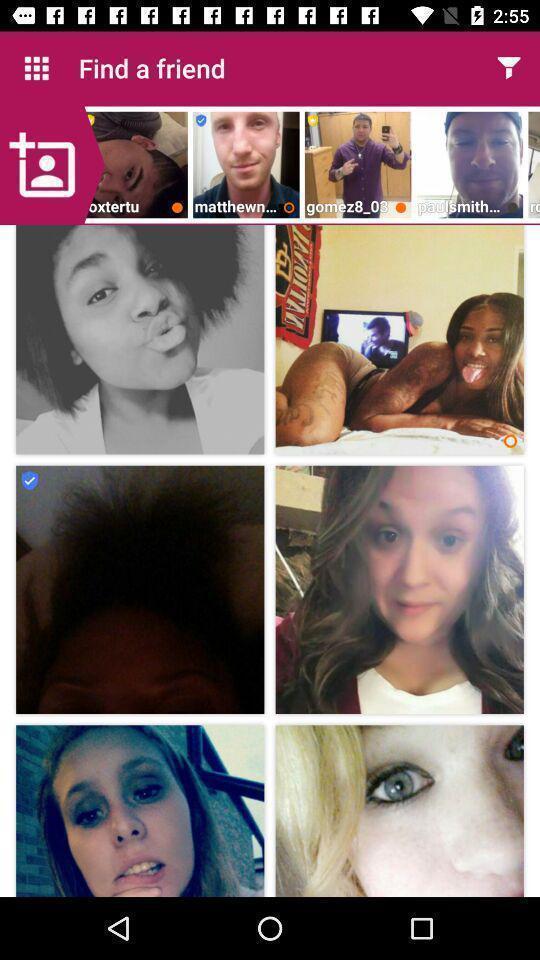Summarize the main components in this picture. Screen showing various images in a dating app. 